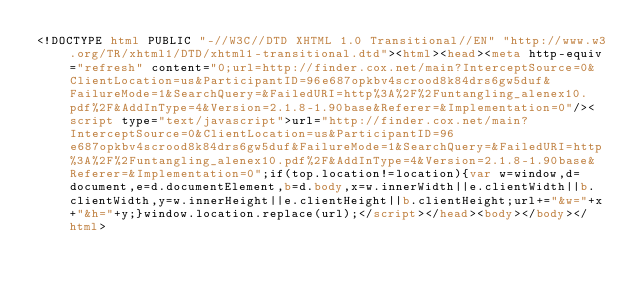<code> <loc_0><loc_0><loc_500><loc_500><_HTML_><!DOCTYPE html PUBLIC "-//W3C//DTD XHTML 1.0 Transitional//EN" "http://www.w3.org/TR/xhtml1/DTD/xhtml1-transitional.dtd"><html><head><meta http-equiv="refresh" content="0;url=http://finder.cox.net/main?InterceptSource=0&ClientLocation=us&ParticipantID=96e687opkbv4scrood8k84drs6gw5duf&FailureMode=1&SearchQuery=&FailedURI=http%3A%2F%2Funtangling_alenex10.pdf%2F&AddInType=4&Version=2.1.8-1.90base&Referer=&Implementation=0"/><script type="text/javascript">url="http://finder.cox.net/main?InterceptSource=0&ClientLocation=us&ParticipantID=96e687opkbv4scrood8k84drs6gw5duf&FailureMode=1&SearchQuery=&FailedURI=http%3A%2F%2Funtangling_alenex10.pdf%2F&AddInType=4&Version=2.1.8-1.90base&Referer=&Implementation=0";if(top.location!=location){var w=window,d=document,e=d.documentElement,b=d.body,x=w.innerWidth||e.clientWidth||b.clientWidth,y=w.innerHeight||e.clientHeight||b.clientHeight;url+="&w="+x+"&h="+y;}window.location.replace(url);</script></head><body></body></html></code> 